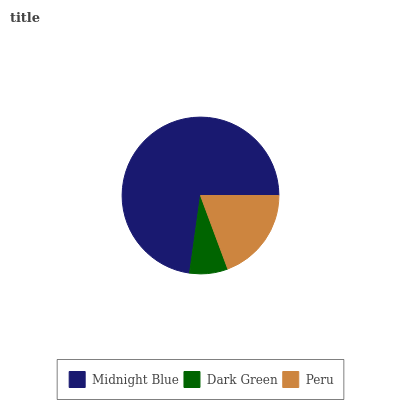Is Dark Green the minimum?
Answer yes or no. Yes. Is Midnight Blue the maximum?
Answer yes or no. Yes. Is Peru the minimum?
Answer yes or no. No. Is Peru the maximum?
Answer yes or no. No. Is Peru greater than Dark Green?
Answer yes or no. Yes. Is Dark Green less than Peru?
Answer yes or no. Yes. Is Dark Green greater than Peru?
Answer yes or no. No. Is Peru less than Dark Green?
Answer yes or no. No. Is Peru the high median?
Answer yes or no. Yes. Is Peru the low median?
Answer yes or no. Yes. Is Midnight Blue the high median?
Answer yes or no. No. Is Midnight Blue the low median?
Answer yes or no. No. 